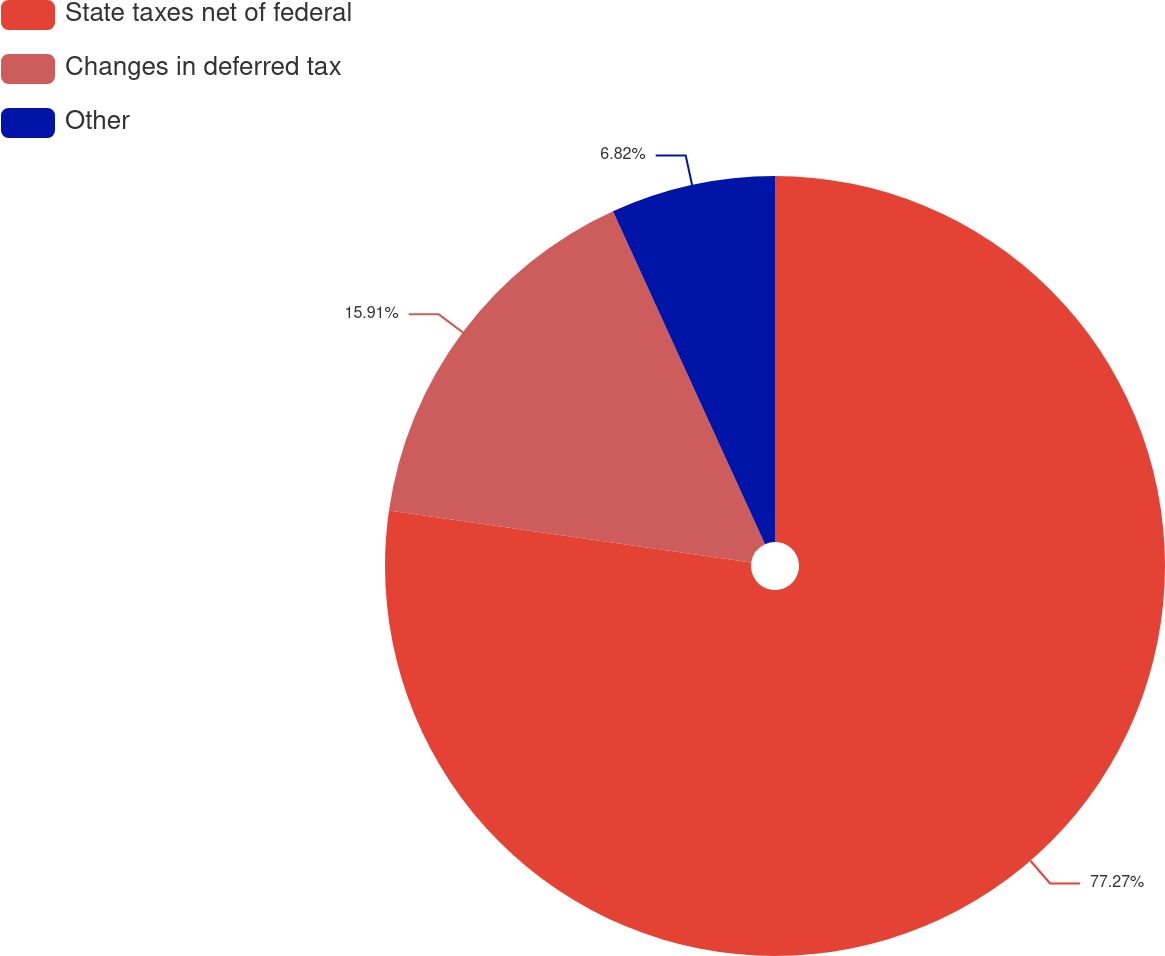Convert chart to OTSL. <chart><loc_0><loc_0><loc_500><loc_500><pie_chart><fcel>State taxes net of federal<fcel>Changes in deferred tax<fcel>Other<nl><fcel>77.27%<fcel>15.91%<fcel>6.82%<nl></chart> 